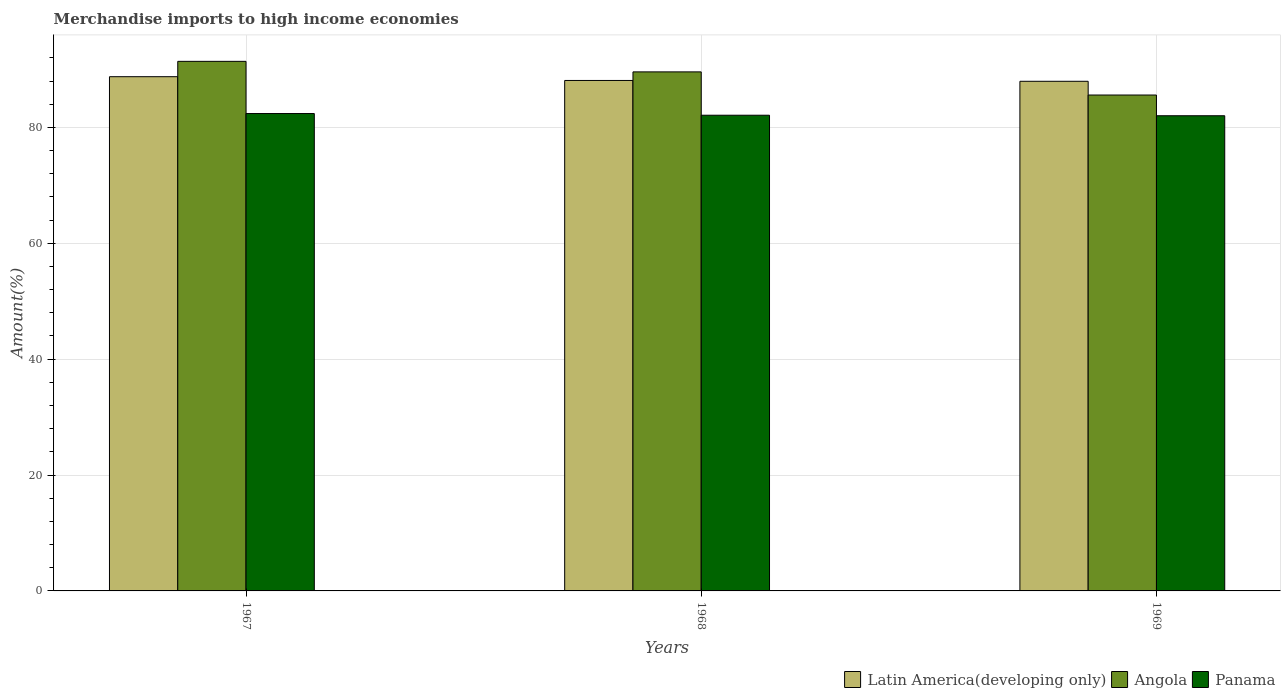How many different coloured bars are there?
Provide a succinct answer. 3. How many groups of bars are there?
Provide a succinct answer. 3. Are the number of bars per tick equal to the number of legend labels?
Your response must be concise. Yes. Are the number of bars on each tick of the X-axis equal?
Give a very brief answer. Yes. How many bars are there on the 1st tick from the left?
Your answer should be compact. 3. How many bars are there on the 3rd tick from the right?
Make the answer very short. 3. What is the label of the 3rd group of bars from the left?
Your answer should be compact. 1969. In how many cases, is the number of bars for a given year not equal to the number of legend labels?
Offer a terse response. 0. What is the percentage of amount earned from merchandise imports in Panama in 1968?
Keep it short and to the point. 82.1. Across all years, what is the maximum percentage of amount earned from merchandise imports in Latin America(developing only)?
Keep it short and to the point. 88.75. Across all years, what is the minimum percentage of amount earned from merchandise imports in Panama?
Your answer should be compact. 82.01. In which year was the percentage of amount earned from merchandise imports in Panama maximum?
Your answer should be very brief. 1967. In which year was the percentage of amount earned from merchandise imports in Latin America(developing only) minimum?
Make the answer very short. 1969. What is the total percentage of amount earned from merchandise imports in Angola in the graph?
Make the answer very short. 266.58. What is the difference between the percentage of amount earned from merchandise imports in Angola in 1967 and that in 1969?
Offer a very short reply. 5.81. What is the difference between the percentage of amount earned from merchandise imports in Angola in 1969 and the percentage of amount earned from merchandise imports in Panama in 1967?
Provide a succinct answer. 3.2. What is the average percentage of amount earned from merchandise imports in Angola per year?
Offer a very short reply. 88.86. In the year 1967, what is the difference between the percentage of amount earned from merchandise imports in Panama and percentage of amount earned from merchandise imports in Latin America(developing only)?
Your answer should be compact. -6.36. What is the ratio of the percentage of amount earned from merchandise imports in Angola in 1967 to that in 1968?
Provide a succinct answer. 1.02. Is the percentage of amount earned from merchandise imports in Latin America(developing only) in 1967 less than that in 1968?
Offer a very short reply. No. Is the difference between the percentage of amount earned from merchandise imports in Panama in 1967 and 1968 greater than the difference between the percentage of amount earned from merchandise imports in Latin America(developing only) in 1967 and 1968?
Make the answer very short. No. What is the difference between the highest and the second highest percentage of amount earned from merchandise imports in Angola?
Ensure brevity in your answer.  1.82. What is the difference between the highest and the lowest percentage of amount earned from merchandise imports in Angola?
Your answer should be very brief. 5.81. In how many years, is the percentage of amount earned from merchandise imports in Panama greater than the average percentage of amount earned from merchandise imports in Panama taken over all years?
Offer a very short reply. 1. What does the 1st bar from the left in 1969 represents?
Your answer should be compact. Latin America(developing only). What does the 3rd bar from the right in 1969 represents?
Offer a terse response. Latin America(developing only). Is it the case that in every year, the sum of the percentage of amount earned from merchandise imports in Latin America(developing only) and percentage of amount earned from merchandise imports in Angola is greater than the percentage of amount earned from merchandise imports in Panama?
Keep it short and to the point. Yes. Does the graph contain any zero values?
Make the answer very short. No. Does the graph contain grids?
Make the answer very short. Yes. Where does the legend appear in the graph?
Ensure brevity in your answer.  Bottom right. How are the legend labels stacked?
Give a very brief answer. Horizontal. What is the title of the graph?
Your answer should be compact. Merchandise imports to high income economies. Does "Turkey" appear as one of the legend labels in the graph?
Ensure brevity in your answer.  No. What is the label or title of the X-axis?
Keep it short and to the point. Years. What is the label or title of the Y-axis?
Your answer should be very brief. Amount(%). What is the Amount(%) of Latin America(developing only) in 1967?
Give a very brief answer. 88.75. What is the Amount(%) in Angola in 1967?
Make the answer very short. 91.4. What is the Amount(%) in Panama in 1967?
Provide a succinct answer. 82.39. What is the Amount(%) of Latin America(developing only) in 1968?
Keep it short and to the point. 88.1. What is the Amount(%) in Angola in 1968?
Offer a very short reply. 89.58. What is the Amount(%) in Panama in 1968?
Provide a short and direct response. 82.1. What is the Amount(%) of Latin America(developing only) in 1969?
Make the answer very short. 87.96. What is the Amount(%) of Angola in 1969?
Your response must be concise. 85.59. What is the Amount(%) in Panama in 1969?
Your answer should be very brief. 82.01. Across all years, what is the maximum Amount(%) in Latin America(developing only)?
Keep it short and to the point. 88.75. Across all years, what is the maximum Amount(%) in Angola?
Your response must be concise. 91.4. Across all years, what is the maximum Amount(%) in Panama?
Your answer should be very brief. 82.39. Across all years, what is the minimum Amount(%) in Latin America(developing only)?
Make the answer very short. 87.96. Across all years, what is the minimum Amount(%) in Angola?
Your answer should be compact. 85.59. Across all years, what is the minimum Amount(%) in Panama?
Make the answer very short. 82.01. What is the total Amount(%) in Latin America(developing only) in the graph?
Give a very brief answer. 264.82. What is the total Amount(%) in Angola in the graph?
Your answer should be very brief. 266.58. What is the total Amount(%) in Panama in the graph?
Ensure brevity in your answer.  246.51. What is the difference between the Amount(%) in Latin America(developing only) in 1967 and that in 1968?
Your response must be concise. 0.65. What is the difference between the Amount(%) of Angola in 1967 and that in 1968?
Offer a very short reply. 1.82. What is the difference between the Amount(%) in Panama in 1967 and that in 1968?
Offer a very short reply. 0.29. What is the difference between the Amount(%) in Latin America(developing only) in 1967 and that in 1969?
Your answer should be very brief. 0.79. What is the difference between the Amount(%) of Angola in 1967 and that in 1969?
Your answer should be very brief. 5.81. What is the difference between the Amount(%) of Panama in 1967 and that in 1969?
Keep it short and to the point. 0.38. What is the difference between the Amount(%) in Latin America(developing only) in 1968 and that in 1969?
Your answer should be very brief. 0.14. What is the difference between the Amount(%) of Angola in 1968 and that in 1969?
Offer a very short reply. 3.99. What is the difference between the Amount(%) in Panama in 1968 and that in 1969?
Provide a succinct answer. 0.09. What is the difference between the Amount(%) in Latin America(developing only) in 1967 and the Amount(%) in Angola in 1968?
Make the answer very short. -0.83. What is the difference between the Amount(%) in Latin America(developing only) in 1967 and the Amount(%) in Panama in 1968?
Offer a terse response. 6.65. What is the difference between the Amount(%) of Angola in 1967 and the Amount(%) of Panama in 1968?
Offer a terse response. 9.3. What is the difference between the Amount(%) in Latin America(developing only) in 1967 and the Amount(%) in Angola in 1969?
Offer a very short reply. 3.16. What is the difference between the Amount(%) in Latin America(developing only) in 1967 and the Amount(%) in Panama in 1969?
Make the answer very short. 6.74. What is the difference between the Amount(%) of Angola in 1967 and the Amount(%) of Panama in 1969?
Offer a terse response. 9.39. What is the difference between the Amount(%) in Latin America(developing only) in 1968 and the Amount(%) in Angola in 1969?
Your response must be concise. 2.51. What is the difference between the Amount(%) of Latin America(developing only) in 1968 and the Amount(%) of Panama in 1969?
Your answer should be very brief. 6.09. What is the difference between the Amount(%) in Angola in 1968 and the Amount(%) in Panama in 1969?
Keep it short and to the point. 7.57. What is the average Amount(%) in Latin America(developing only) per year?
Provide a short and direct response. 88.27. What is the average Amount(%) in Angola per year?
Your answer should be compact. 88.86. What is the average Amount(%) of Panama per year?
Keep it short and to the point. 82.17. In the year 1967, what is the difference between the Amount(%) in Latin America(developing only) and Amount(%) in Angola?
Provide a succinct answer. -2.65. In the year 1967, what is the difference between the Amount(%) of Latin America(developing only) and Amount(%) of Panama?
Your answer should be very brief. 6.36. In the year 1967, what is the difference between the Amount(%) in Angola and Amount(%) in Panama?
Give a very brief answer. 9.01. In the year 1968, what is the difference between the Amount(%) in Latin America(developing only) and Amount(%) in Angola?
Your answer should be compact. -1.48. In the year 1968, what is the difference between the Amount(%) of Latin America(developing only) and Amount(%) of Panama?
Ensure brevity in your answer.  6. In the year 1968, what is the difference between the Amount(%) of Angola and Amount(%) of Panama?
Make the answer very short. 7.48. In the year 1969, what is the difference between the Amount(%) of Latin America(developing only) and Amount(%) of Angola?
Offer a terse response. 2.37. In the year 1969, what is the difference between the Amount(%) in Latin America(developing only) and Amount(%) in Panama?
Your answer should be compact. 5.95. In the year 1969, what is the difference between the Amount(%) of Angola and Amount(%) of Panama?
Ensure brevity in your answer.  3.58. What is the ratio of the Amount(%) of Latin America(developing only) in 1967 to that in 1968?
Your answer should be compact. 1.01. What is the ratio of the Amount(%) in Angola in 1967 to that in 1968?
Keep it short and to the point. 1.02. What is the ratio of the Amount(%) in Panama in 1967 to that in 1968?
Keep it short and to the point. 1. What is the ratio of the Amount(%) of Latin America(developing only) in 1967 to that in 1969?
Give a very brief answer. 1.01. What is the ratio of the Amount(%) in Angola in 1967 to that in 1969?
Offer a very short reply. 1.07. What is the ratio of the Amount(%) of Panama in 1967 to that in 1969?
Offer a terse response. 1. What is the ratio of the Amount(%) of Latin America(developing only) in 1968 to that in 1969?
Ensure brevity in your answer.  1. What is the ratio of the Amount(%) of Angola in 1968 to that in 1969?
Provide a short and direct response. 1.05. What is the ratio of the Amount(%) of Panama in 1968 to that in 1969?
Offer a terse response. 1. What is the difference between the highest and the second highest Amount(%) in Latin America(developing only)?
Keep it short and to the point. 0.65. What is the difference between the highest and the second highest Amount(%) of Angola?
Keep it short and to the point. 1.82. What is the difference between the highest and the second highest Amount(%) of Panama?
Give a very brief answer. 0.29. What is the difference between the highest and the lowest Amount(%) of Latin America(developing only)?
Your answer should be compact. 0.79. What is the difference between the highest and the lowest Amount(%) of Angola?
Offer a terse response. 5.81. What is the difference between the highest and the lowest Amount(%) in Panama?
Your answer should be compact. 0.38. 